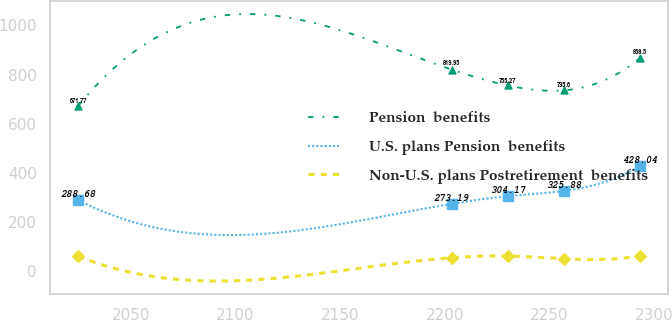<chart> <loc_0><loc_0><loc_500><loc_500><line_chart><ecel><fcel>Pension  benefits<fcel>U.S. plans Pension  benefits<fcel>Non-U.S. plans Postretirement  benefits<nl><fcel>2024.85<fcel>671.77<fcel>288.68<fcel>59.39<nl><fcel>2203.3<fcel>819.95<fcel>273.19<fcel>53.59<nl><fcel>2230.15<fcel>755.27<fcel>304.17<fcel>60.59<nl><fcel>2257<fcel>735.6<fcel>325.88<fcel>49.31<nl><fcel>2293.39<fcel>868.5<fcel>428.04<fcel>61.79<nl></chart> 